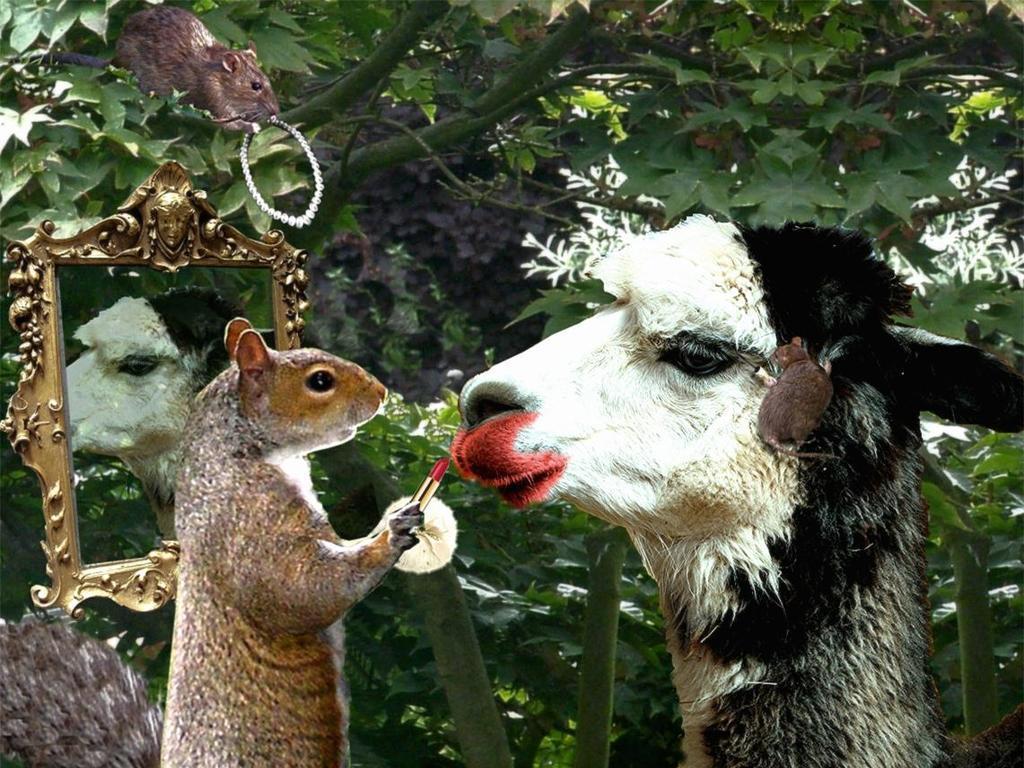Could you give a brief overview of what you see in this image? I see this is an edited image and I see a squirrel over here which is holding 2 things in hands and I see 2 rats in which this one is holding a thing and this one is on an animal which is of white and black in color and I see a mirror over here. In the background I see the tree. 